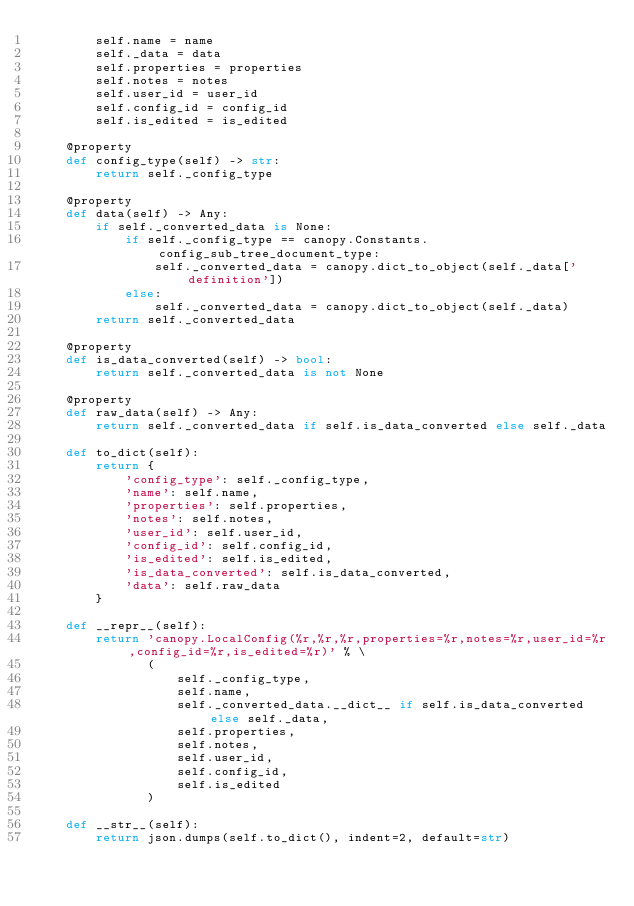<code> <loc_0><loc_0><loc_500><loc_500><_Python_>        self.name = name
        self._data = data
        self.properties = properties
        self.notes = notes
        self.user_id = user_id
        self.config_id = config_id
        self.is_edited = is_edited

    @property
    def config_type(self) -> str:
        return self._config_type

    @property
    def data(self) -> Any:
        if self._converted_data is None:
            if self._config_type == canopy.Constants.config_sub_tree_document_type:
                self._converted_data = canopy.dict_to_object(self._data['definition'])
            else:
                self._converted_data = canopy.dict_to_object(self._data)
        return self._converted_data

    @property
    def is_data_converted(self) -> bool:
        return self._converted_data is not None

    @property
    def raw_data(self) -> Any:
        return self._converted_data if self.is_data_converted else self._data

    def to_dict(self):
        return {
            'config_type': self._config_type,
            'name': self.name,
            'properties': self.properties,
            'notes': self.notes,
            'user_id': self.user_id,
            'config_id': self.config_id,
            'is_edited': self.is_edited,
            'is_data_converted': self.is_data_converted,
            'data': self.raw_data
        }

    def __repr__(self):
        return 'canopy.LocalConfig(%r,%r,%r,properties=%r,notes=%r,user_id=%r,config_id=%r,is_edited=%r)' % \
               (
                   self._config_type,
                   self.name,
                   self._converted_data.__dict__ if self.is_data_converted else self._data,
                   self.properties,
                   self.notes,
                   self.user_id,
                   self.config_id,
                   self.is_edited
               )

    def __str__(self):
        return json.dumps(self.to_dict(), indent=2, default=str)
</code> 